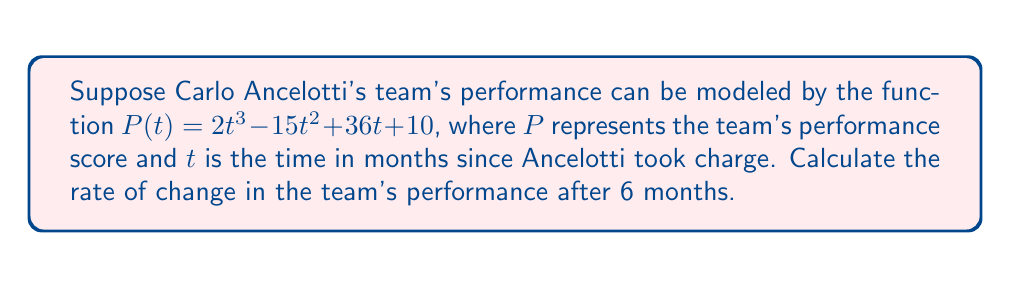Provide a solution to this math problem. To find the rate of change in the team's performance, we need to calculate the derivative of the performance function $P(t)$ and then evaluate it at $t=6$. Let's break this down step-by-step:

1) The performance function is $P(t) = 2t^3 - 15t^2 + 36t + 10$

2) To find the rate of change, we need to calculate $\frac{dP}{dt}$:
   
   $\frac{dP}{dt} = \frac{d}{dt}(2t^3 - 15t^2 + 36t + 10)$

3) Using the power rule and the constant rule of differentiation:
   
   $\frac{dP}{dt} = 6t^2 - 30t + 36$

4) Now, we need to evaluate this at $t=6$:
   
   $\frac{dP}{dt}|_{t=6} = 6(6)^2 - 30(6) + 36$

5) Simplifying:
   
   $\frac{dP}{dt}|_{t=6} = 6(36) - 180 + 36$
   $\frac{dP}{dt}|_{t=6} = 216 - 180 + 36 = 72$

Therefore, after 6 months, the rate of change in the team's performance is 72 units per month.
Answer: $72$ units per month 